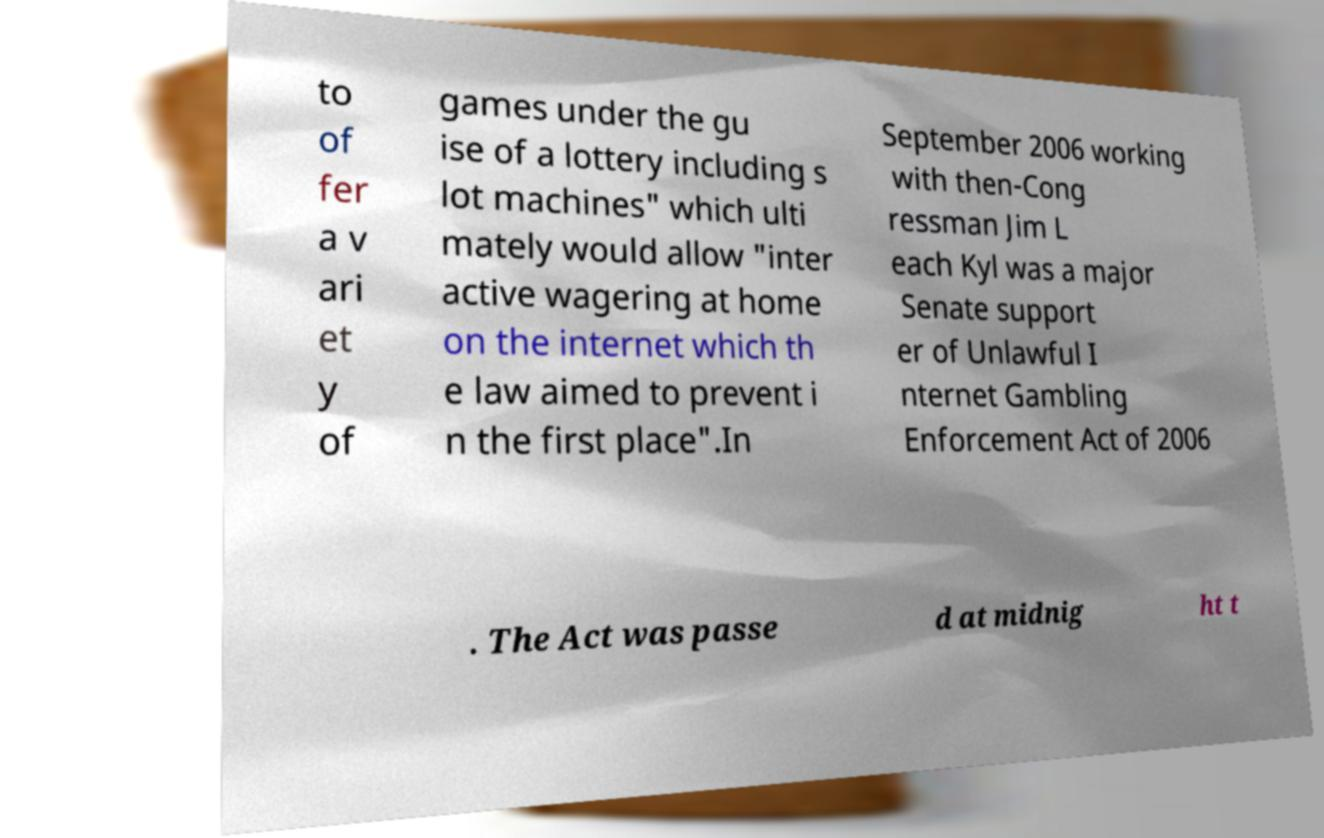I need the written content from this picture converted into text. Can you do that? to of fer a v ari et y of games under the gu ise of a lottery including s lot machines" which ulti mately would allow "inter active wagering at home on the internet which th e law aimed to prevent i n the first place".In September 2006 working with then-Cong ressman Jim L each Kyl was a major Senate support er of Unlawful I nternet Gambling Enforcement Act of 2006 . The Act was passe d at midnig ht t 